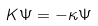Convert formula to latex. <formula><loc_0><loc_0><loc_500><loc_500>K \Psi = - \kappa \Psi</formula> 